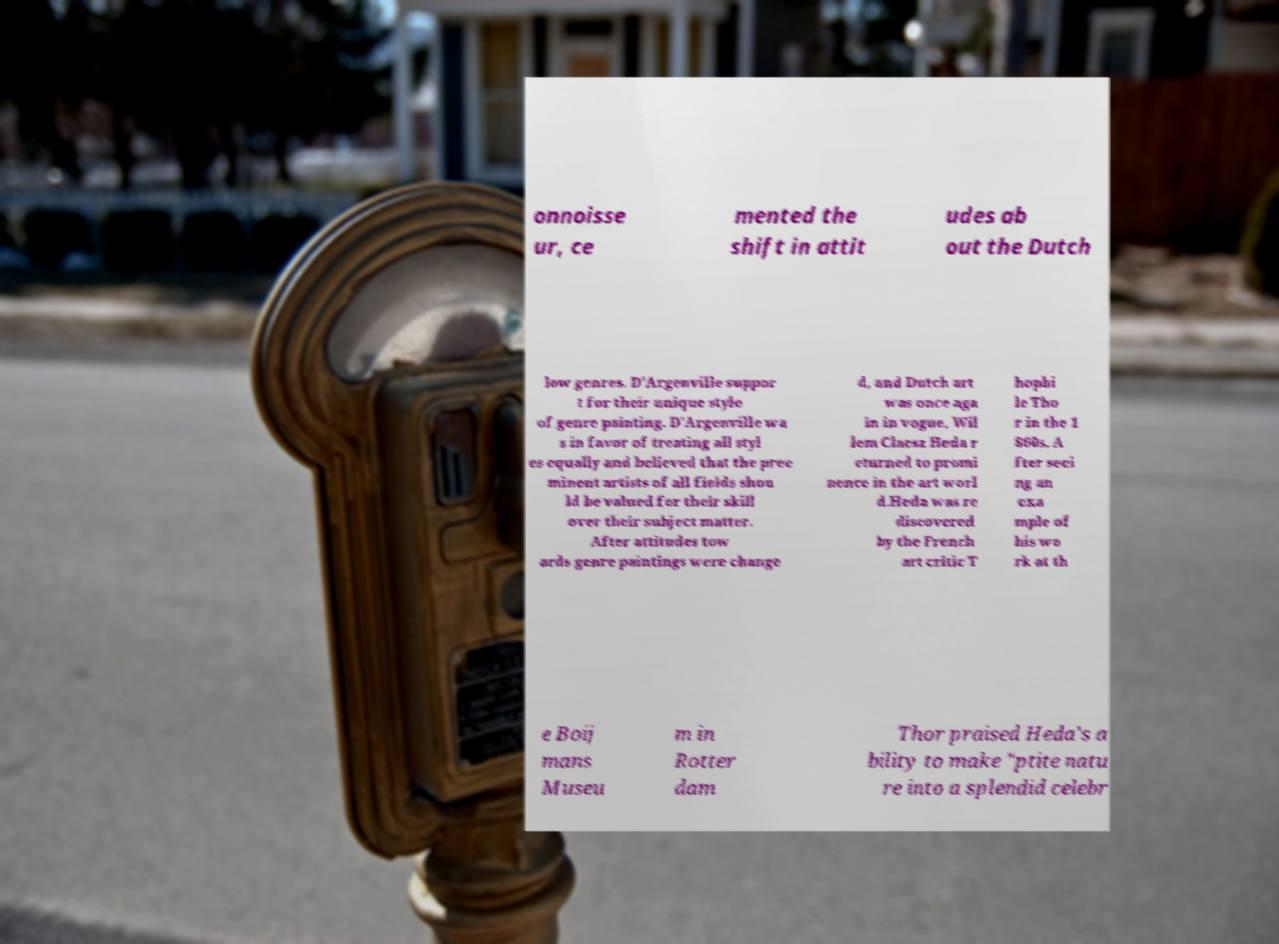There's text embedded in this image that I need extracted. Can you transcribe it verbatim? onnoisse ur, ce mented the shift in attit udes ab out the Dutch low genres. D'Argenville suppor t for their unique style of genre painting. D'Argenville wa s in favor of treating all styl es equally and believed that the pree minent artists of all fields shou ld be valued for their skill over their subject matter. After attitudes tow ards genre paintings were change d, and Dutch art was once aga in in vogue, Wil lem Claesz Heda r eturned to promi nence in the art worl d.Heda was re discovered by the French art critic T hophi le Tho r in the 1 860s. A fter seei ng an exa mple of his wo rk at th e Boij mans Museu m in Rotter dam Thor praised Heda's a bility to make "ptite natu re into a splendid celebr 